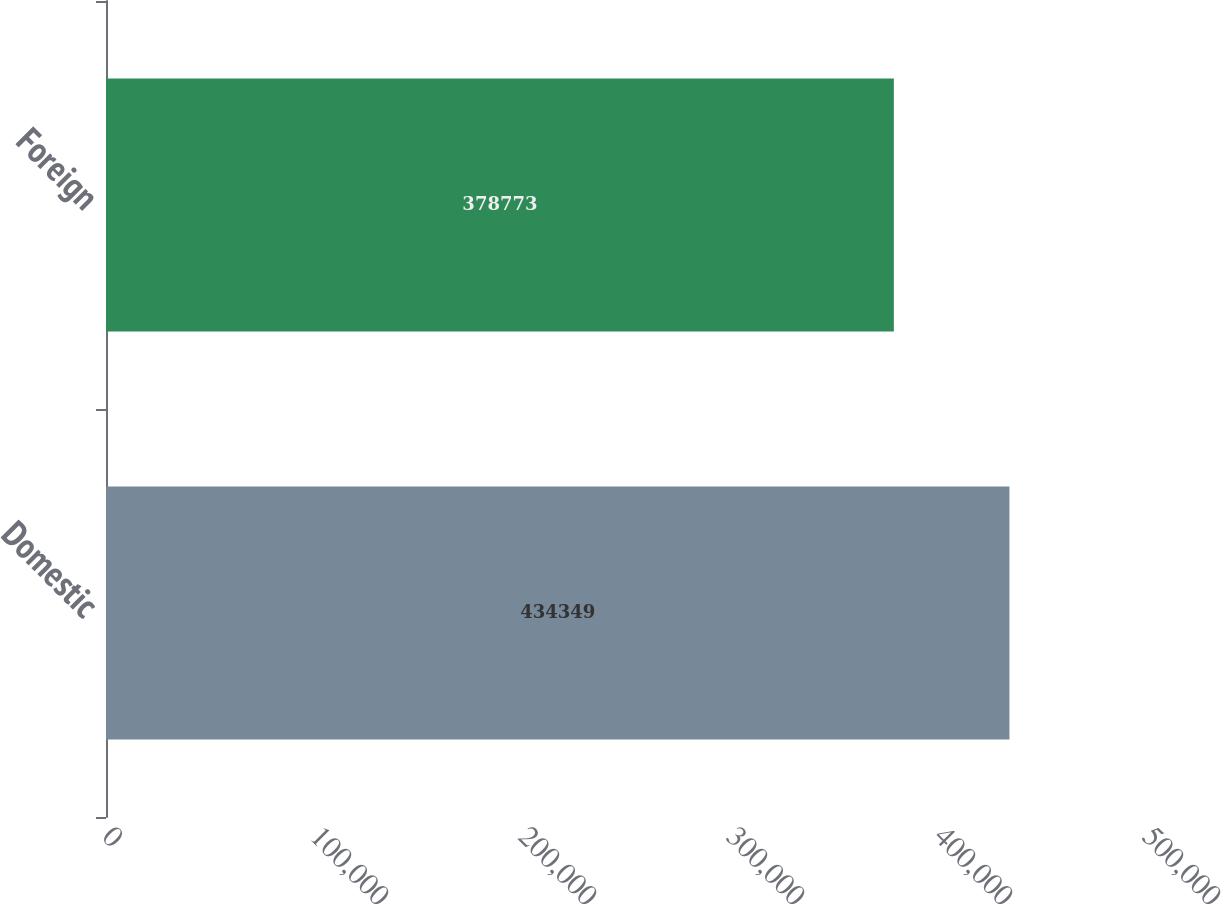Convert chart. <chart><loc_0><loc_0><loc_500><loc_500><bar_chart><fcel>Domestic<fcel>Foreign<nl><fcel>434349<fcel>378773<nl></chart> 